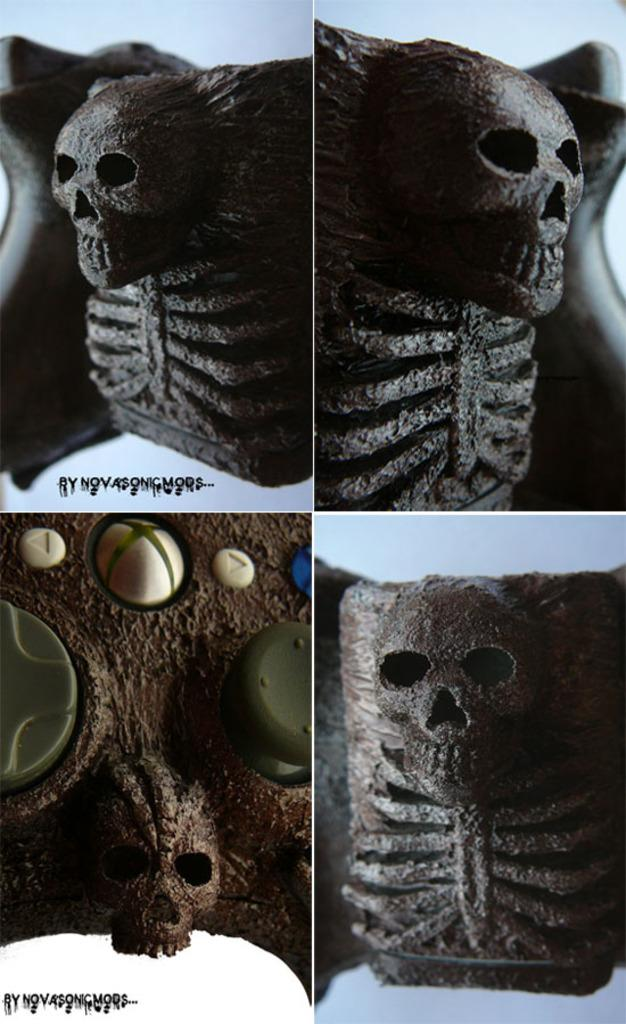What type of artwork is depicted in the image? The image contains collage frames. What is featured in each of the frames? Each frame contains a skull. Is there any additional information or marking in the image? Yes, there is a watermark in the bottom left corner of the image. What type of instrument is being played on the dock in the image? There is no instrument or dock present in the image; it features collage frames with skulls and a watermark. 